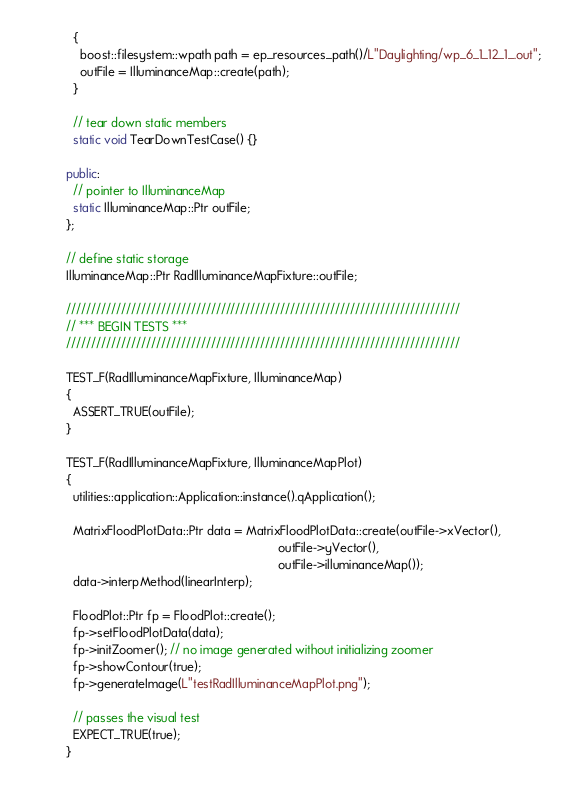Convert code to text. <code><loc_0><loc_0><loc_500><loc_500><_C++_>  {
    boost::filesystem::wpath path = ep_resources_path()/L"Daylighting/wp_6_1_12_1_.out";
    outFile = IlluminanceMap::create(path);
  }

  // tear down static members
  static void TearDownTestCase() {}

public:
  // pointer to IlluminanceMap
  static IlluminanceMap::Ptr outFile;
};

// define static storage
IlluminanceMap::Ptr RadIlluminanceMapFixture::outFile;

///////////////////////////////////////////////////////////////////////////////
// *** BEGIN TESTS ***
///////////////////////////////////////////////////////////////////////////////

TEST_F(RadIlluminanceMapFixture, IlluminanceMap)
{
  ASSERT_TRUE(outFile);
}

TEST_F(RadIlluminanceMapFixture, IlluminanceMapPlot)
{
  utilities::application::Application::instance().qApplication();

  MatrixFloodPlotData::Ptr data = MatrixFloodPlotData::create(outFile->xVector(),
                                                              outFile->yVector(),
                                                              outFile->illuminanceMap());
  data->interpMethod(linearInterp);

  FloodPlot::Ptr fp = FloodPlot::create();
  fp->setFloodPlotData(data);
  fp->initZoomer(); // no image generated without initializing zoomer
  fp->showContour(true);
  fp->generateImage(L"testRadIlluminanceMapPlot.png");

  // passes the visual test
  EXPECT_TRUE(true);
}
</code> 